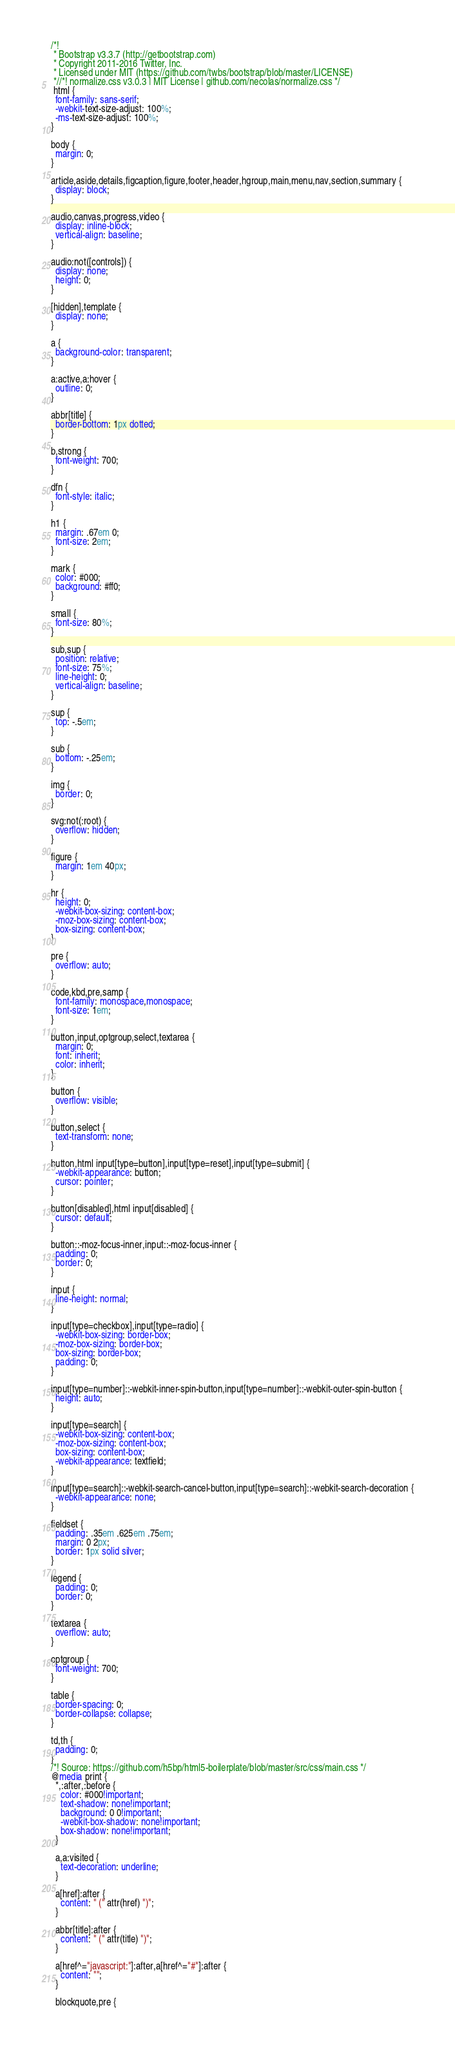Convert code to text. <code><loc_0><loc_0><loc_500><loc_500><_CSS_>/*!
 * Bootstrap v3.3.7 (http://getbootstrap.com)
 * Copyright 2011-2016 Twitter, Inc.
 * Licensed under MIT (https://github.com/twbs/bootstrap/blob/master/LICENSE)
 *//*! normalize.css v3.0.3 | MIT License | github.com/necolas/normalize.css */
 html {
  font-family: sans-serif;
  -webkit-text-size-adjust: 100%;
  -ms-text-size-adjust: 100%;
}

body {
  margin: 0;
}

article,aside,details,figcaption,figure,footer,header,hgroup,main,menu,nav,section,summary {
  display: block;
}

audio,canvas,progress,video {
  display: inline-block;
  vertical-align: baseline;
}

audio:not([controls]) {
  display: none;
  height: 0;
}

[hidden],template {
  display: none;
}

a {
  background-color: transparent;
}

a:active,a:hover {
  outline: 0;
}

abbr[title] {
  border-bottom: 1px dotted;
}

b,strong {
  font-weight: 700;
}

dfn {
  font-style: italic;
}

h1 {
  margin: .67em 0;
  font-size: 2em;
}

mark {
  color: #000;
  background: #ff0;
}

small {
  font-size: 80%;
}

sub,sup {
  position: relative;
  font-size: 75%;
  line-height: 0;
  vertical-align: baseline;
}

sup {
  top: -.5em;
}

sub {
  bottom: -.25em;
}

img {
  border: 0;
}

svg:not(:root) {
  overflow: hidden;
}

figure {
  margin: 1em 40px;
}

hr {
  height: 0;
  -webkit-box-sizing: content-box;
  -moz-box-sizing: content-box;
  box-sizing: content-box;
}

pre {
  overflow: auto;
}

code,kbd,pre,samp {
  font-family: monospace,monospace;
  font-size: 1em;
}

button,input,optgroup,select,textarea {
  margin: 0;
  font: inherit;
  color: inherit;
}

button {
  overflow: visible;
}

button,select {
  text-transform: none;
}

button,html input[type=button],input[type=reset],input[type=submit] {
  -webkit-appearance: button;
  cursor: pointer;
}

button[disabled],html input[disabled] {
  cursor: default;
}

button::-moz-focus-inner,input::-moz-focus-inner {
  padding: 0;
  border: 0;
}

input {
  line-height: normal;
}

input[type=checkbox],input[type=radio] {
  -webkit-box-sizing: border-box;
  -moz-box-sizing: border-box;
  box-sizing: border-box;
  padding: 0;
}

input[type=number]::-webkit-inner-spin-button,input[type=number]::-webkit-outer-spin-button {
  height: auto;
}

input[type=search] {
  -webkit-box-sizing: content-box;
  -moz-box-sizing: content-box;
  box-sizing: content-box;
  -webkit-appearance: textfield;
}

input[type=search]::-webkit-search-cancel-button,input[type=search]::-webkit-search-decoration {
  -webkit-appearance: none;
}

fieldset {
  padding: .35em .625em .75em;
  margin: 0 2px;
  border: 1px solid silver;
}

legend {
  padding: 0;
  border: 0;
}

textarea {
  overflow: auto;
}

optgroup {
  font-weight: 700;
}

table {
  border-spacing: 0;
  border-collapse: collapse;
}

td,th {
  padding: 0;
}
/*! Source: https://github.com/h5bp/html5-boilerplate/blob/master/src/css/main.css */
@media print {
  *,:after,:before {
    color: #000!important;
    text-shadow: none!important;
    background: 0 0!important;
    -webkit-box-shadow: none!important;
    box-shadow: none!important;
  }

  a,a:visited {
    text-decoration: underline;
  }

  a[href]:after {
    content: " (" attr(href) ")";
  }

  abbr[title]:after {
    content: " (" attr(title) ")";
  }

  a[href^="javascript:"]:after,a[href^="#"]:after {
    content: "";
  }

  blockquote,pre {</code> 